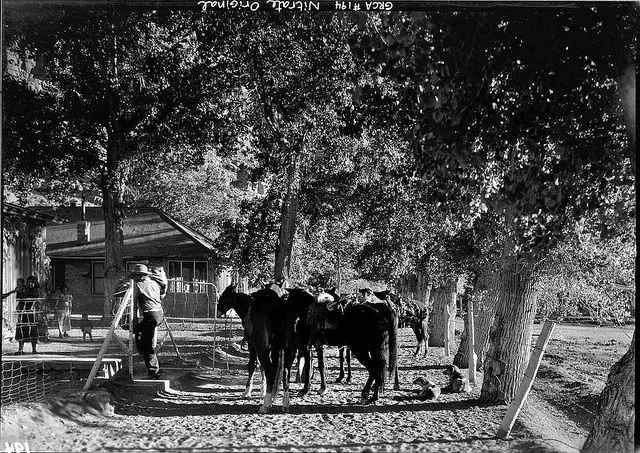Describe the objects in this image and their specific colors. I can see horse in black, gray, darkgray, and lightgray tones, horse in black, gray, darkgray, and lightgray tones, people in black, lightgray, darkgray, and gray tones, people in black, gray, darkgray, and lightgray tones, and horse in black, gray, darkgray, and lightgray tones in this image. 